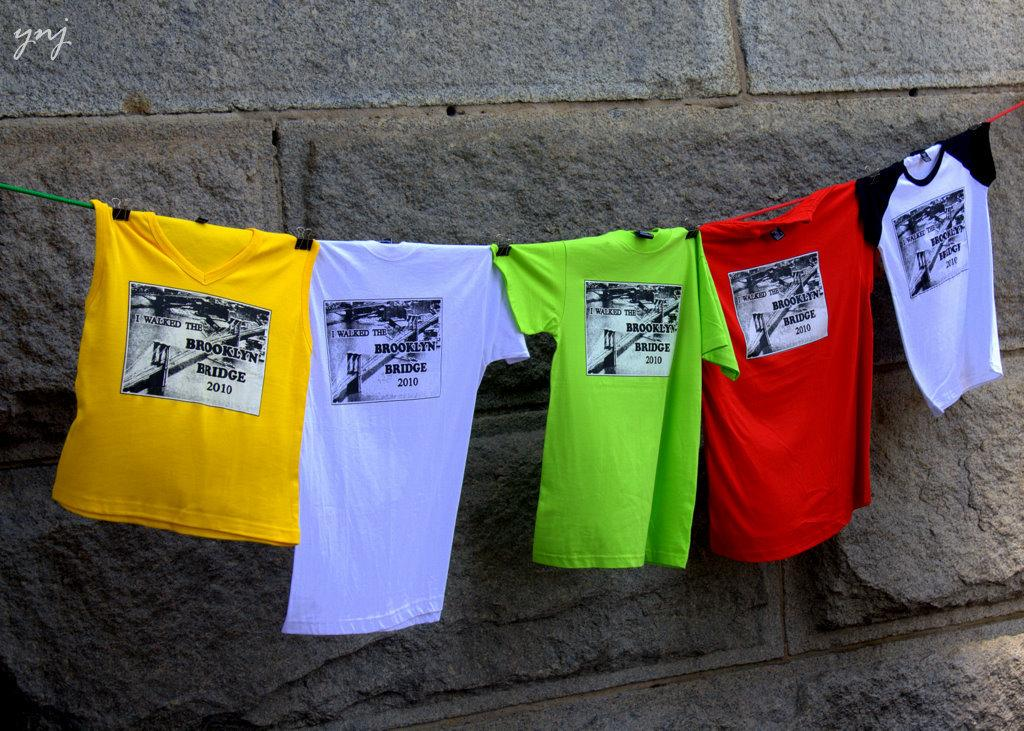What is the main subject of the picture? The main subject of the picture is t-shirts. How are the t-shirts arranged in the image? The t-shirts are on a rope in the center of the picture. What can be observed about the t-shirts' appearance? The t-shirts are of different colors. What is visible in the background of the image? There is a wall in the background of the image. What type of agreement is being signed by the crook in the image? There is no crook or agreement present in the image; it features t-shirts on a rope. 